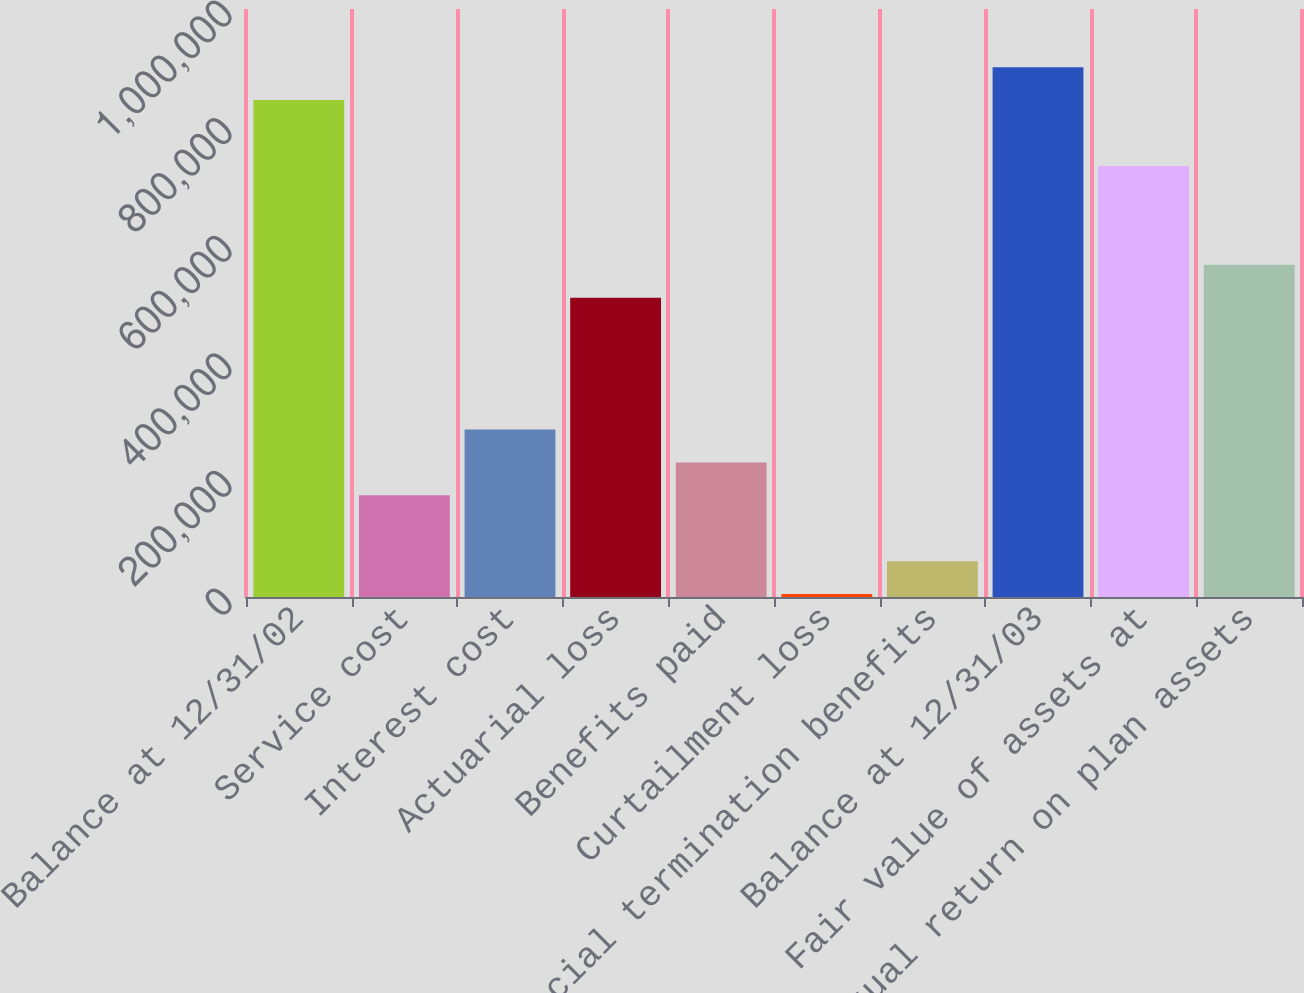<chart> <loc_0><loc_0><loc_500><loc_500><bar_chart><fcel>Balance at 12/31/02<fcel>Service cost<fcel>Interest cost<fcel>Actuarial loss<fcel>Benefits paid<fcel>Curtailment loss<fcel>Special termination benefits<fcel>Balance at 12/31/03<fcel>Fair value of assets at<fcel>Actual return on plan assets<nl><fcel>845056<fcel>172931<fcel>284952<fcel>508994<fcel>228942<fcel>4900<fcel>60910.4<fcel>901066<fcel>733035<fcel>565004<nl></chart> 